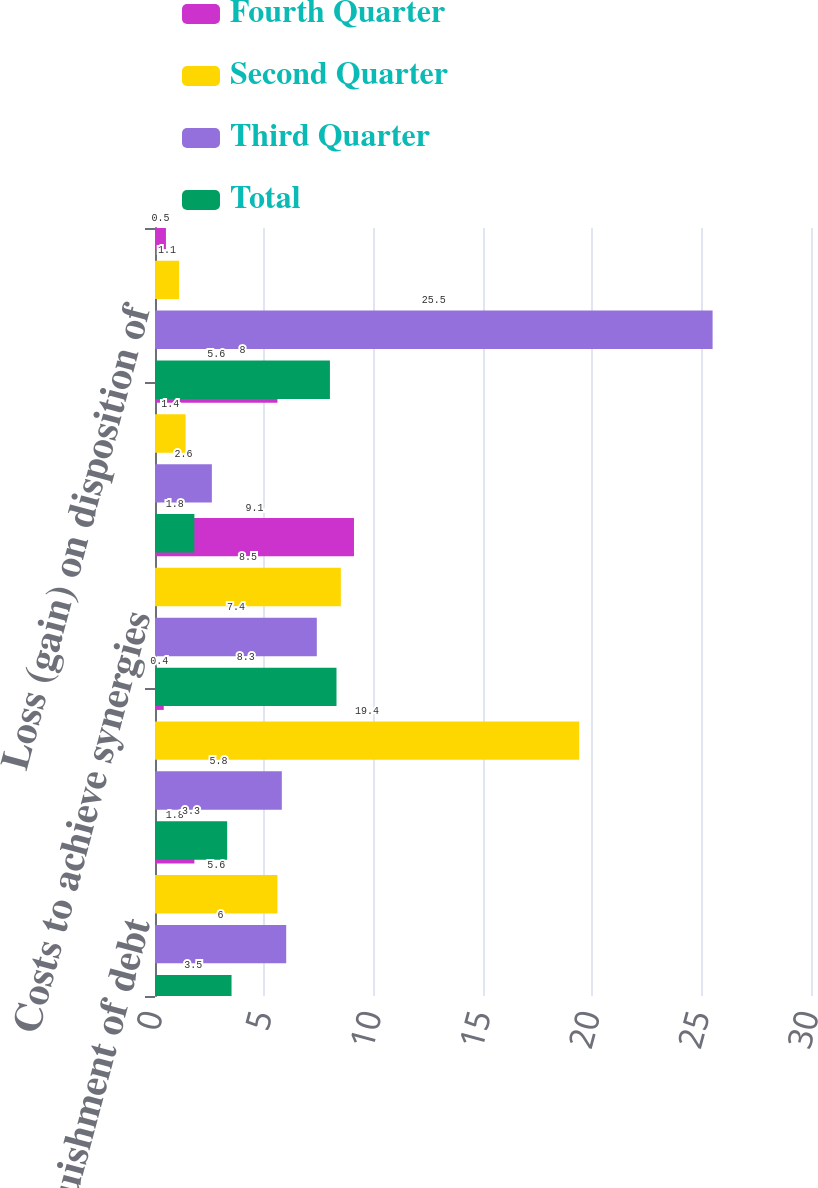Convert chart. <chart><loc_0><loc_0><loc_500><loc_500><stacked_bar_chart><ecel><fcel>Loss on extinguishment of debt<fcel>(Gain) loss on disposition of<fcel>Costs to achieve synergies<fcel>Restructuring charges<fcel>Loss (gain) on disposition of<nl><fcel>Fourth Quarter<fcel>1.8<fcel>0.4<fcel>9.1<fcel>5.6<fcel>0.5<nl><fcel>Second Quarter<fcel>5.6<fcel>19.4<fcel>8.5<fcel>1.4<fcel>1.1<nl><fcel>Third Quarter<fcel>6<fcel>5.8<fcel>7.4<fcel>2.6<fcel>25.5<nl><fcel>Total<fcel>3.5<fcel>3.3<fcel>8.3<fcel>1.8<fcel>8<nl></chart> 